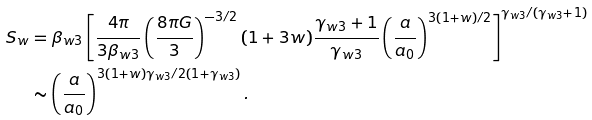<formula> <loc_0><loc_0><loc_500><loc_500>S _ { w } & = \beta _ { w 3 } \left [ \frac { 4 \pi } { 3 \beta _ { w 3 } } \left ( \frac { 8 \pi G } { 3 } \right ) ^ { - 3 / 2 } ( 1 + 3 w ) \frac { \gamma _ { w 3 } + 1 } { \gamma _ { w 3 } } \left ( \frac { a } { a _ { 0 } } \right ) ^ { 3 ( 1 + w ) / 2 } \right ] ^ { \gamma _ { w 3 } / ( \gamma _ { w 3 } + 1 ) } \\ & \sim \left ( \frac { a } { a _ { 0 } } \right ) ^ { 3 ( 1 + w ) \gamma _ { w 3 } / 2 ( 1 + \gamma _ { w 3 } ) } .</formula> 